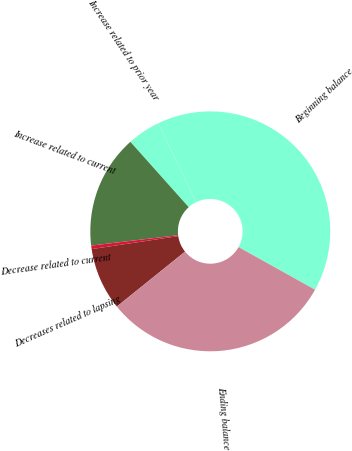Convert chart. <chart><loc_0><loc_0><loc_500><loc_500><pie_chart><fcel>Beginning balance<fcel>Increase related to prior year<fcel>Increase related to current<fcel>Decrease related to current<fcel>Decreases related to lapsing<fcel>Ending balance<nl><fcel>40.24%<fcel>4.45%<fcel>15.3%<fcel>0.47%<fcel>8.42%<fcel>31.12%<nl></chart> 